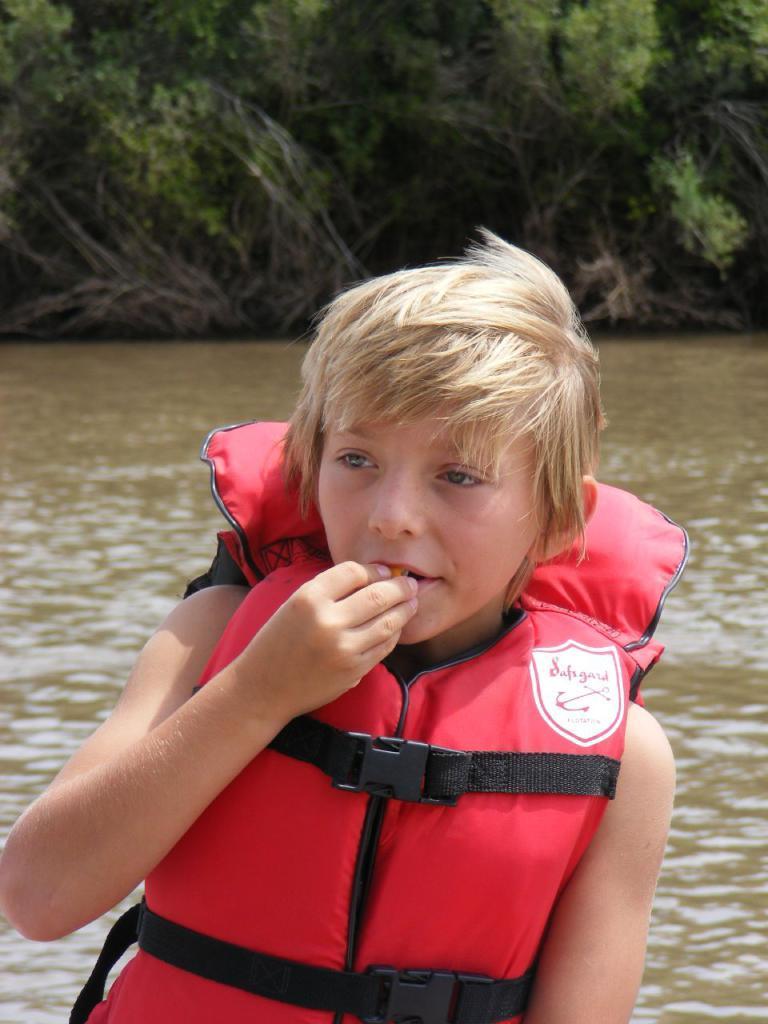In one or two sentences, can you explain what this image depicts? In this image we can see a child wearing a jacket. On the backside we can see a water body and a group of plants. 